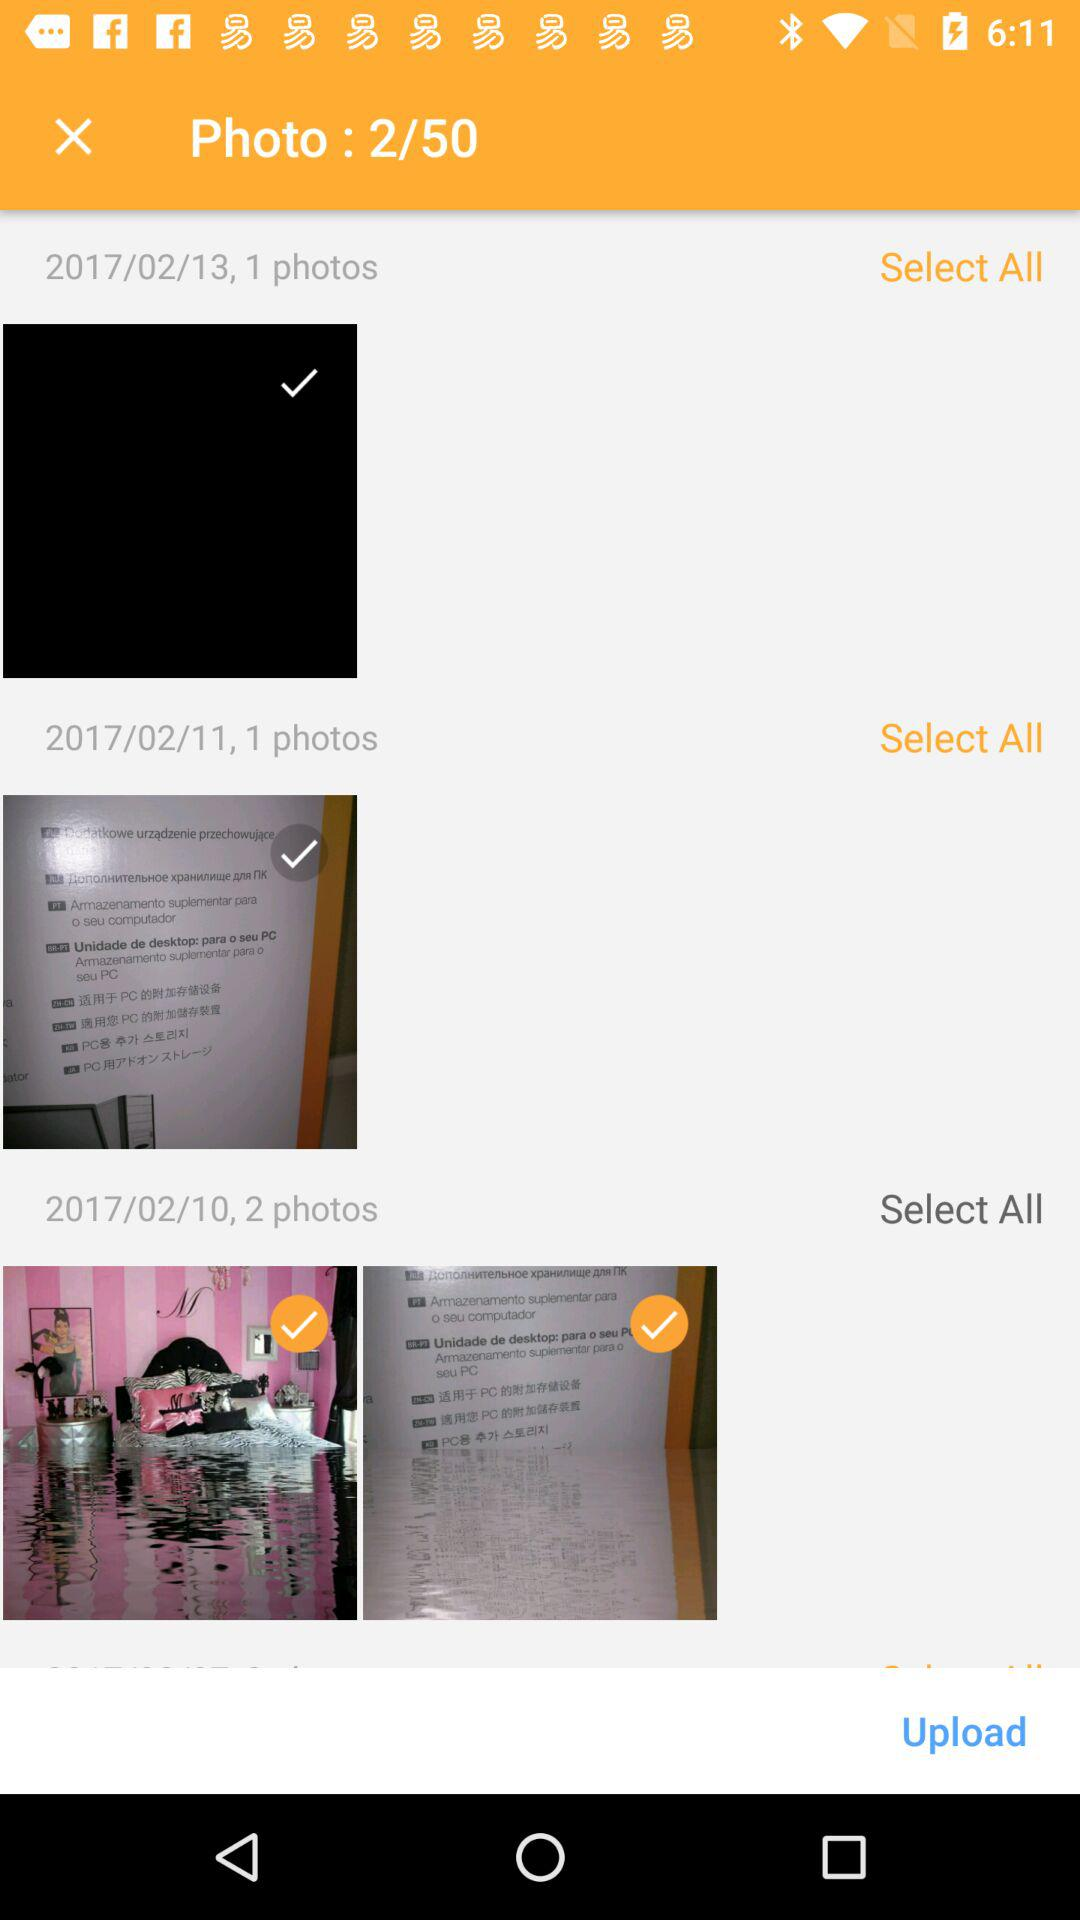How many photos have been selected? There are 2 photos selected. 